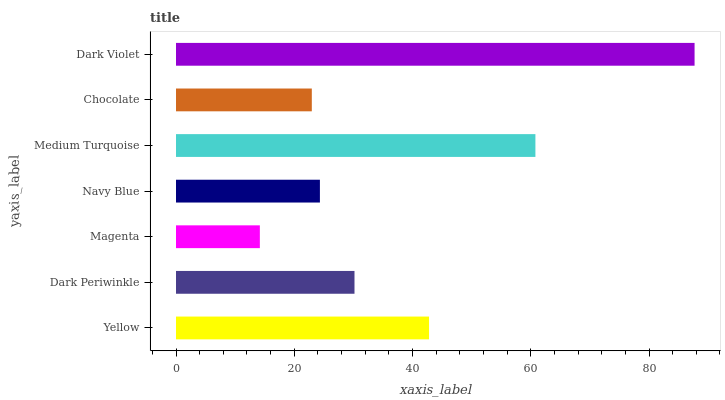Is Magenta the minimum?
Answer yes or no. Yes. Is Dark Violet the maximum?
Answer yes or no. Yes. Is Dark Periwinkle the minimum?
Answer yes or no. No. Is Dark Periwinkle the maximum?
Answer yes or no. No. Is Yellow greater than Dark Periwinkle?
Answer yes or no. Yes. Is Dark Periwinkle less than Yellow?
Answer yes or no. Yes. Is Dark Periwinkle greater than Yellow?
Answer yes or no. No. Is Yellow less than Dark Periwinkle?
Answer yes or no. No. Is Dark Periwinkle the high median?
Answer yes or no. Yes. Is Dark Periwinkle the low median?
Answer yes or no. Yes. Is Yellow the high median?
Answer yes or no. No. Is Chocolate the low median?
Answer yes or no. No. 